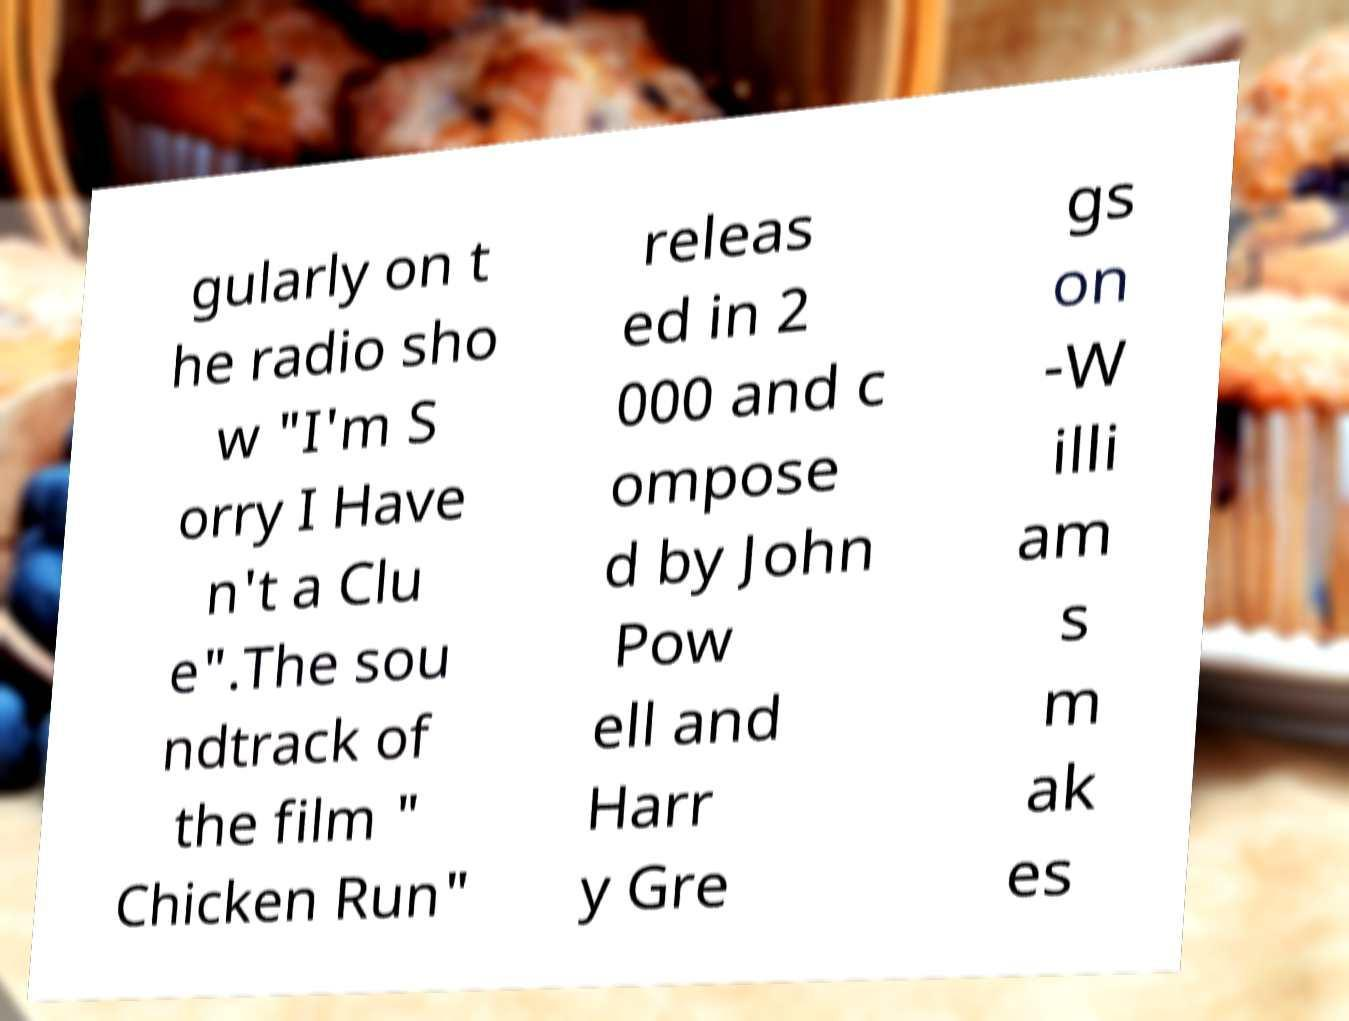Can you accurately transcribe the text from the provided image for me? gularly on t he radio sho w "I'm S orry I Have n't a Clu e".The sou ndtrack of the film " Chicken Run" releas ed in 2 000 and c ompose d by John Pow ell and Harr y Gre gs on -W illi am s m ak es 